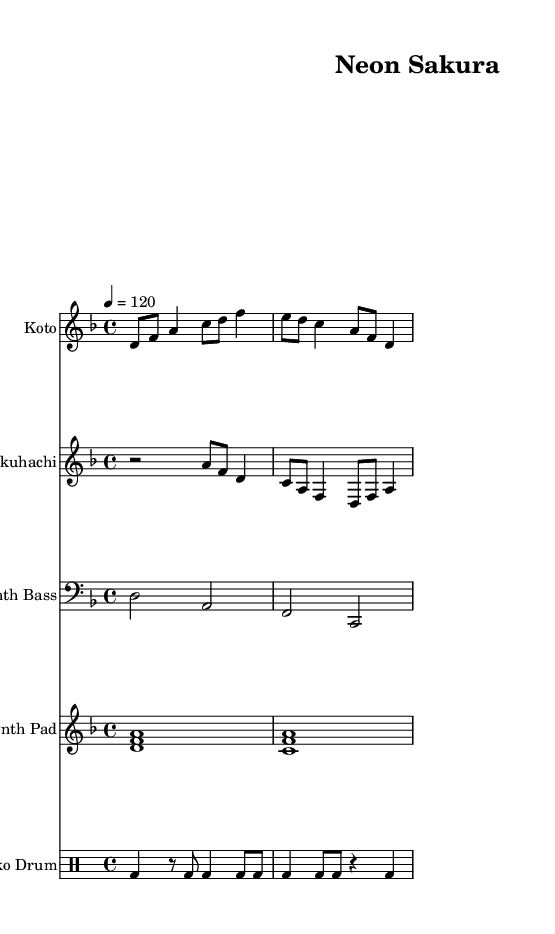What is the key signature of this music? The key signature is indicated at the beginning of the score. In this case, it is D minor, which has one flat (B♭).
Answer: D minor What is the time signature of this music? The time signature appears at the start of the sheet music. Here, it is 4/4, which means there are four beats in a measure.
Answer: 4/4 What is the tempo marking for this piece? The tempo is noted at the beginning of the music as a metronome marking of 120 beats per minute, indicating the speed at which it should be played.
Answer: 120 How many instruments are featured in the score? By counting the separate staves in the score, we see there are five instruments: Koto, Shakuhachi, Synth Bass, Synth Pad, and Taiko Drum.
Answer: Five Which instrument is featured in the highest register? The Shakuhachi notation is written in the treble clef and uses higher pitches compared to the other instruments, making it the highest in range.
Answer: Shakuhachi What kind of rhythm pattern does the Taiko Drum play? Looking at the notation for the Taiko Drum, it consists of a repeated bass drum pattern featuring both accented and unaccented beats, indicative of a driving rhythm typical in electronic music.
Answer: Repeated bass pattern What notable feature does the Koto part have in relation to harmonic progression? The Koto plays a series of melodic notes that serve as chord tones, creating structures that blend harmonically with the synth parts, which is a signature characteristic of experimental electronic music.
Answer: Melodic chord tones 